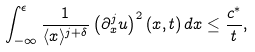<formula> <loc_0><loc_0><loc_500><loc_500>\int _ { - \infty } ^ { \epsilon } \frac { 1 } { \langle x \rangle ^ { j + \delta } } \left ( \partial _ { x } ^ { j } u \right ) ^ { 2 } ( x , t ) \, d x \leq \frac { c ^ { * } } { t } ,</formula> 